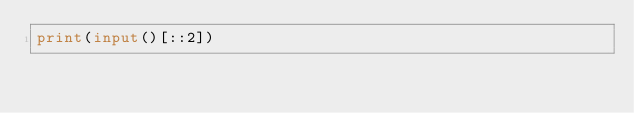Convert code to text. <code><loc_0><loc_0><loc_500><loc_500><_Python_>print(input()[::2])
</code> 